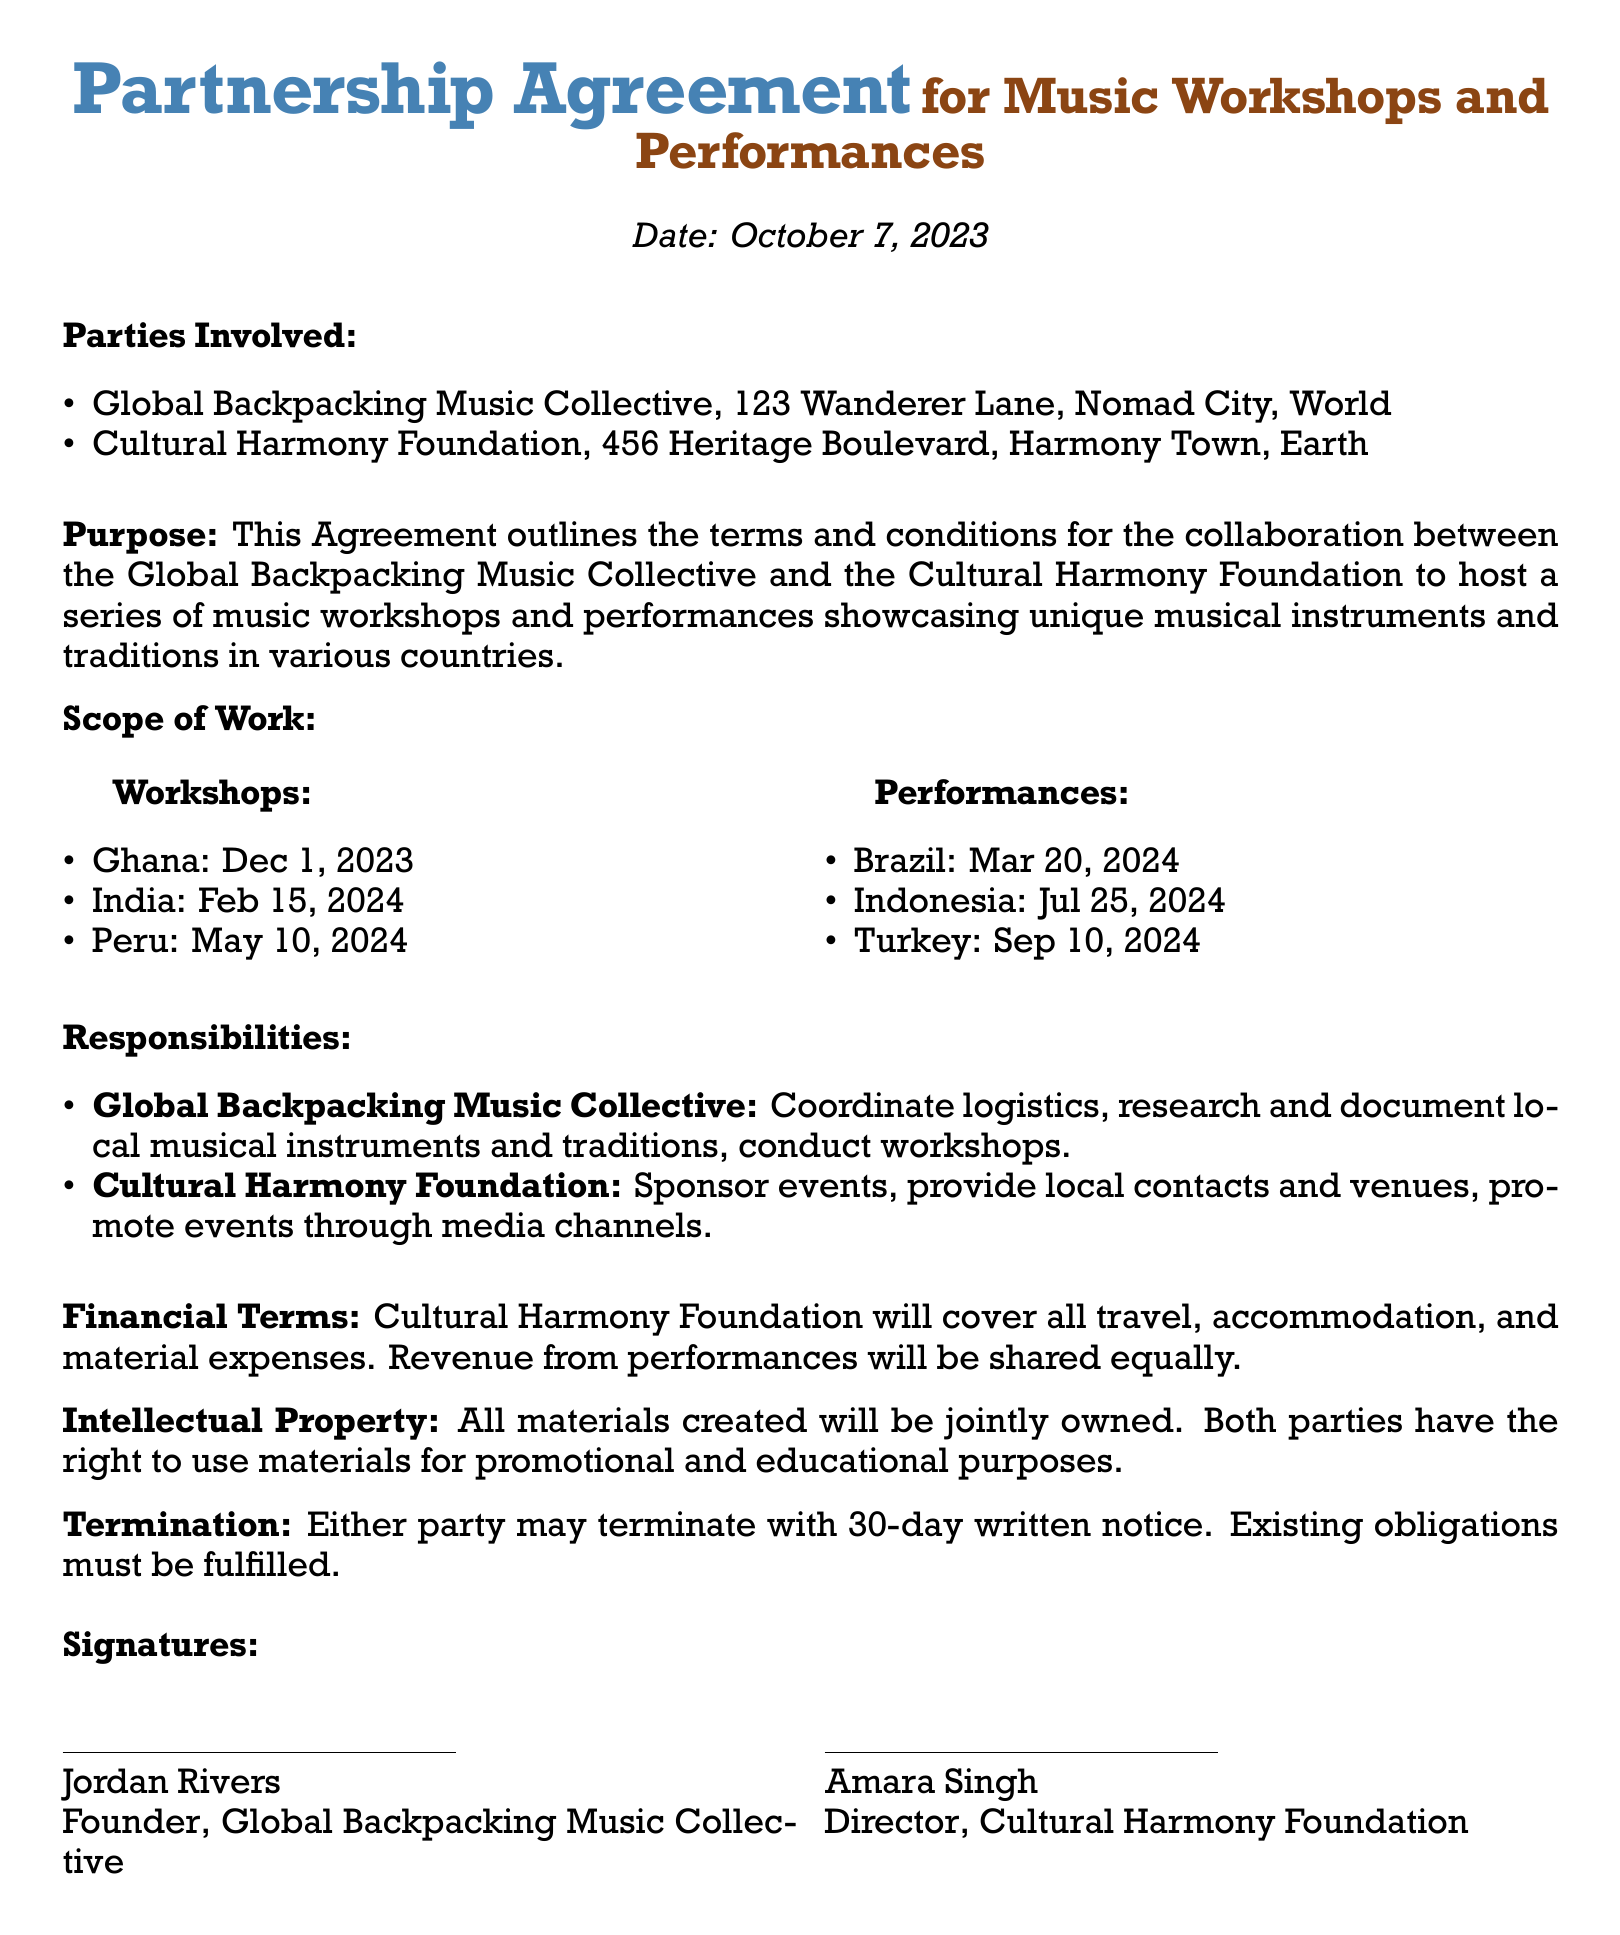what is the date of the agreement? The document states that the date is October 7, 2023.
Answer: October 7, 2023 who is the founder of the Global Backpacking Music Collective? The signatory for the Global Backpacking Music Collective is Jordan Rivers.
Answer: Jordan Rivers what are the three countries listed for workshops? The document lists workshops in Ghana, India, and Peru.
Answer: Ghana, India, Peru how will the revenue from performances be shared? The financial terms specify that revenue from performances will be shared equally.
Answer: Equally what is the notice period for termination? The termination clause states that either party may terminate with a 30-day written notice.
Answer: 30-day who is responsible for coordinating logistics? The responsibilities section states that coordinating logistics is the duty of the Global Backpacking Music Collective.
Answer: Global Backpacking Music Collective when is the performance scheduled in Brazil? The document specifies the performance in Brazil is scheduled for March 20, 2024.
Answer: March 20, 2024 what type of ownership do both parties have over created materials? The intellectual property clause states that all materials created will be jointly owned.
Answer: Jointly owned 